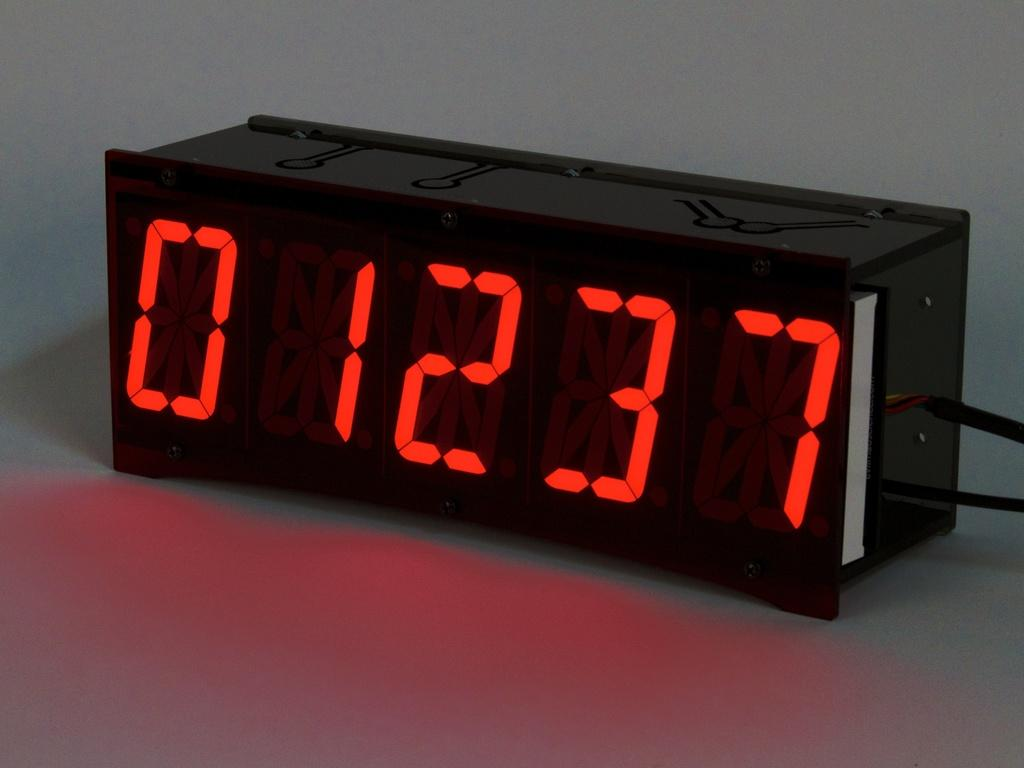<image>
Create a compact narrative representing the image presented. A black clock with the time 1237 display on face. 